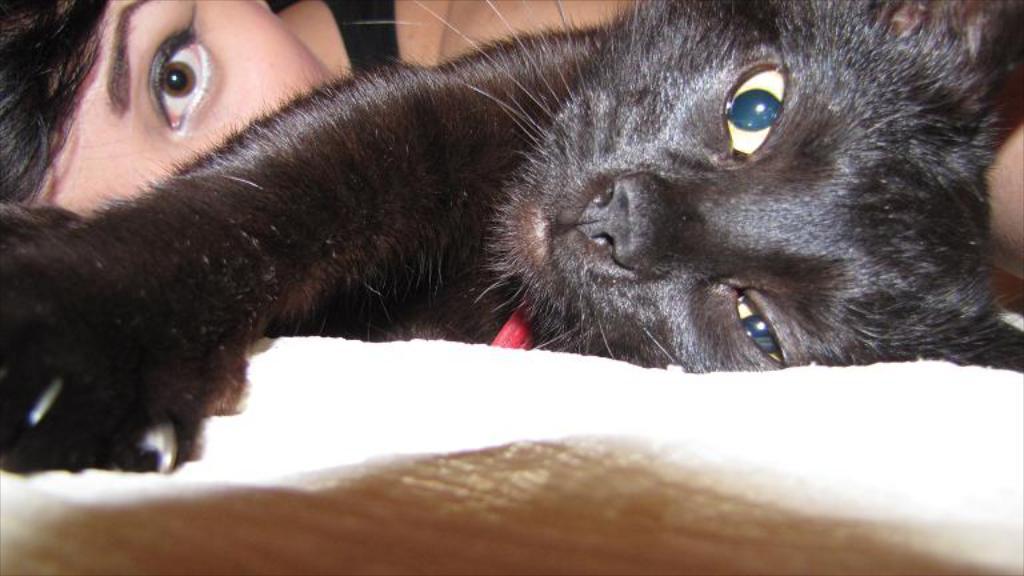Could you give a brief overview of what you see in this image? In this image I can see a woman and a cat. 